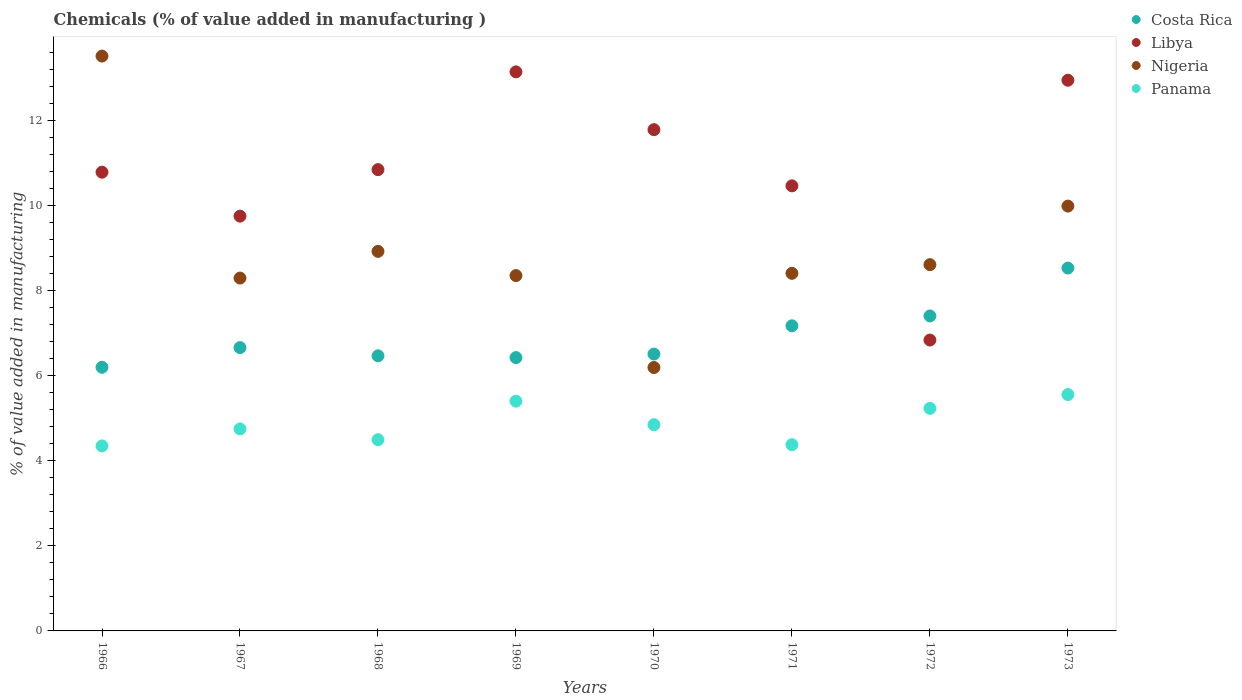What is the value added in manufacturing chemicals in Panama in 1971?
Your answer should be very brief. 4.38. Across all years, what is the maximum value added in manufacturing chemicals in Nigeria?
Your answer should be very brief. 13.52. Across all years, what is the minimum value added in manufacturing chemicals in Libya?
Keep it short and to the point. 6.84. In which year was the value added in manufacturing chemicals in Panama minimum?
Ensure brevity in your answer.  1966. What is the total value added in manufacturing chemicals in Libya in the graph?
Provide a succinct answer. 86.56. What is the difference between the value added in manufacturing chemicals in Costa Rica in 1967 and that in 1969?
Offer a very short reply. 0.24. What is the difference between the value added in manufacturing chemicals in Costa Rica in 1971 and the value added in manufacturing chemicals in Libya in 1967?
Your answer should be very brief. -2.58. What is the average value added in manufacturing chemicals in Panama per year?
Keep it short and to the point. 4.88. In the year 1971, what is the difference between the value added in manufacturing chemicals in Nigeria and value added in manufacturing chemicals in Costa Rica?
Provide a succinct answer. 1.23. In how many years, is the value added in manufacturing chemicals in Costa Rica greater than 7.2 %?
Provide a succinct answer. 2. What is the ratio of the value added in manufacturing chemicals in Panama in 1966 to that in 1970?
Your response must be concise. 0.9. What is the difference between the highest and the second highest value added in manufacturing chemicals in Costa Rica?
Provide a short and direct response. 1.13. What is the difference between the highest and the lowest value added in manufacturing chemicals in Costa Rica?
Your answer should be compact. 2.33. Does the value added in manufacturing chemicals in Costa Rica monotonically increase over the years?
Make the answer very short. No. Is the value added in manufacturing chemicals in Nigeria strictly greater than the value added in manufacturing chemicals in Libya over the years?
Offer a terse response. No. Is the value added in manufacturing chemicals in Libya strictly less than the value added in manufacturing chemicals in Costa Rica over the years?
Give a very brief answer. No. How many years are there in the graph?
Offer a terse response. 8. What is the difference between two consecutive major ticks on the Y-axis?
Provide a short and direct response. 2. Are the values on the major ticks of Y-axis written in scientific E-notation?
Your answer should be very brief. No. How are the legend labels stacked?
Offer a very short reply. Vertical. What is the title of the graph?
Provide a short and direct response. Chemicals (% of value added in manufacturing ). Does "Bahrain" appear as one of the legend labels in the graph?
Provide a succinct answer. No. What is the label or title of the X-axis?
Your answer should be compact. Years. What is the label or title of the Y-axis?
Offer a very short reply. % of value added in manufacturing. What is the % of value added in manufacturing in Costa Rica in 1966?
Offer a very short reply. 6.2. What is the % of value added in manufacturing in Libya in 1966?
Your response must be concise. 10.78. What is the % of value added in manufacturing of Nigeria in 1966?
Provide a short and direct response. 13.52. What is the % of value added in manufacturing of Panama in 1966?
Provide a short and direct response. 4.35. What is the % of value added in manufacturing of Costa Rica in 1967?
Your answer should be very brief. 6.66. What is the % of value added in manufacturing in Libya in 1967?
Your answer should be compact. 9.75. What is the % of value added in manufacturing of Nigeria in 1967?
Provide a short and direct response. 8.3. What is the % of value added in manufacturing in Panama in 1967?
Your answer should be compact. 4.75. What is the % of value added in manufacturing of Costa Rica in 1968?
Keep it short and to the point. 6.47. What is the % of value added in manufacturing of Libya in 1968?
Make the answer very short. 10.85. What is the % of value added in manufacturing in Nigeria in 1968?
Your response must be concise. 8.92. What is the % of value added in manufacturing of Panama in 1968?
Make the answer very short. 4.5. What is the % of value added in manufacturing of Costa Rica in 1969?
Provide a short and direct response. 6.43. What is the % of value added in manufacturing of Libya in 1969?
Your answer should be compact. 13.14. What is the % of value added in manufacturing of Nigeria in 1969?
Offer a terse response. 8.35. What is the % of value added in manufacturing in Panama in 1969?
Your answer should be compact. 5.4. What is the % of value added in manufacturing of Costa Rica in 1970?
Keep it short and to the point. 6.51. What is the % of value added in manufacturing in Libya in 1970?
Ensure brevity in your answer.  11.79. What is the % of value added in manufacturing of Nigeria in 1970?
Make the answer very short. 6.19. What is the % of value added in manufacturing of Panama in 1970?
Provide a short and direct response. 4.85. What is the % of value added in manufacturing in Costa Rica in 1971?
Provide a short and direct response. 7.17. What is the % of value added in manufacturing of Libya in 1971?
Make the answer very short. 10.46. What is the % of value added in manufacturing in Nigeria in 1971?
Make the answer very short. 8.41. What is the % of value added in manufacturing in Panama in 1971?
Make the answer very short. 4.38. What is the % of value added in manufacturing of Costa Rica in 1972?
Your response must be concise. 7.41. What is the % of value added in manufacturing in Libya in 1972?
Keep it short and to the point. 6.84. What is the % of value added in manufacturing in Nigeria in 1972?
Give a very brief answer. 8.61. What is the % of value added in manufacturing in Panama in 1972?
Your response must be concise. 5.23. What is the % of value added in manufacturing in Costa Rica in 1973?
Your answer should be very brief. 8.53. What is the % of value added in manufacturing of Libya in 1973?
Offer a very short reply. 12.95. What is the % of value added in manufacturing in Nigeria in 1973?
Your answer should be very brief. 9.99. What is the % of value added in manufacturing of Panama in 1973?
Give a very brief answer. 5.56. Across all years, what is the maximum % of value added in manufacturing of Costa Rica?
Your answer should be compact. 8.53. Across all years, what is the maximum % of value added in manufacturing in Libya?
Keep it short and to the point. 13.14. Across all years, what is the maximum % of value added in manufacturing of Nigeria?
Keep it short and to the point. 13.52. Across all years, what is the maximum % of value added in manufacturing in Panama?
Your answer should be very brief. 5.56. Across all years, what is the minimum % of value added in manufacturing of Costa Rica?
Provide a short and direct response. 6.2. Across all years, what is the minimum % of value added in manufacturing of Libya?
Provide a succinct answer. 6.84. Across all years, what is the minimum % of value added in manufacturing of Nigeria?
Give a very brief answer. 6.19. Across all years, what is the minimum % of value added in manufacturing in Panama?
Your response must be concise. 4.35. What is the total % of value added in manufacturing in Costa Rica in the graph?
Your answer should be very brief. 55.37. What is the total % of value added in manufacturing of Libya in the graph?
Your response must be concise. 86.56. What is the total % of value added in manufacturing in Nigeria in the graph?
Offer a very short reply. 72.29. What is the total % of value added in manufacturing in Panama in the graph?
Ensure brevity in your answer.  39.01. What is the difference between the % of value added in manufacturing of Costa Rica in 1966 and that in 1967?
Provide a succinct answer. -0.46. What is the difference between the % of value added in manufacturing in Libya in 1966 and that in 1967?
Provide a short and direct response. 1.03. What is the difference between the % of value added in manufacturing in Nigeria in 1966 and that in 1967?
Provide a succinct answer. 5.22. What is the difference between the % of value added in manufacturing of Panama in 1966 and that in 1967?
Offer a terse response. -0.4. What is the difference between the % of value added in manufacturing of Costa Rica in 1966 and that in 1968?
Give a very brief answer. -0.27. What is the difference between the % of value added in manufacturing of Libya in 1966 and that in 1968?
Ensure brevity in your answer.  -0.06. What is the difference between the % of value added in manufacturing of Nigeria in 1966 and that in 1968?
Offer a very short reply. 4.59. What is the difference between the % of value added in manufacturing in Panama in 1966 and that in 1968?
Offer a very short reply. -0.15. What is the difference between the % of value added in manufacturing in Costa Rica in 1966 and that in 1969?
Your answer should be compact. -0.23. What is the difference between the % of value added in manufacturing of Libya in 1966 and that in 1969?
Ensure brevity in your answer.  -2.36. What is the difference between the % of value added in manufacturing in Nigeria in 1966 and that in 1969?
Offer a terse response. 5.16. What is the difference between the % of value added in manufacturing of Panama in 1966 and that in 1969?
Offer a very short reply. -1.05. What is the difference between the % of value added in manufacturing of Costa Rica in 1966 and that in 1970?
Your answer should be compact. -0.31. What is the difference between the % of value added in manufacturing in Libya in 1966 and that in 1970?
Provide a short and direct response. -1. What is the difference between the % of value added in manufacturing of Nigeria in 1966 and that in 1970?
Keep it short and to the point. 7.32. What is the difference between the % of value added in manufacturing of Panama in 1966 and that in 1970?
Your response must be concise. -0.5. What is the difference between the % of value added in manufacturing of Costa Rica in 1966 and that in 1971?
Make the answer very short. -0.97. What is the difference between the % of value added in manufacturing of Libya in 1966 and that in 1971?
Provide a succinct answer. 0.32. What is the difference between the % of value added in manufacturing in Nigeria in 1966 and that in 1971?
Keep it short and to the point. 5.11. What is the difference between the % of value added in manufacturing in Panama in 1966 and that in 1971?
Your answer should be compact. -0.03. What is the difference between the % of value added in manufacturing in Costa Rica in 1966 and that in 1972?
Keep it short and to the point. -1.21. What is the difference between the % of value added in manufacturing of Libya in 1966 and that in 1972?
Your answer should be very brief. 3.95. What is the difference between the % of value added in manufacturing in Nigeria in 1966 and that in 1972?
Your answer should be very brief. 4.9. What is the difference between the % of value added in manufacturing in Panama in 1966 and that in 1972?
Offer a very short reply. -0.88. What is the difference between the % of value added in manufacturing of Costa Rica in 1966 and that in 1973?
Offer a terse response. -2.33. What is the difference between the % of value added in manufacturing of Libya in 1966 and that in 1973?
Give a very brief answer. -2.16. What is the difference between the % of value added in manufacturing of Nigeria in 1966 and that in 1973?
Provide a succinct answer. 3.53. What is the difference between the % of value added in manufacturing in Panama in 1966 and that in 1973?
Provide a succinct answer. -1.21. What is the difference between the % of value added in manufacturing of Costa Rica in 1967 and that in 1968?
Offer a terse response. 0.19. What is the difference between the % of value added in manufacturing of Libya in 1967 and that in 1968?
Ensure brevity in your answer.  -1.09. What is the difference between the % of value added in manufacturing of Nigeria in 1967 and that in 1968?
Your answer should be compact. -0.63. What is the difference between the % of value added in manufacturing of Panama in 1967 and that in 1968?
Provide a short and direct response. 0.25. What is the difference between the % of value added in manufacturing of Costa Rica in 1967 and that in 1969?
Make the answer very short. 0.24. What is the difference between the % of value added in manufacturing in Libya in 1967 and that in 1969?
Provide a short and direct response. -3.39. What is the difference between the % of value added in manufacturing of Nigeria in 1967 and that in 1969?
Offer a very short reply. -0.06. What is the difference between the % of value added in manufacturing of Panama in 1967 and that in 1969?
Provide a succinct answer. -0.65. What is the difference between the % of value added in manufacturing of Costa Rica in 1967 and that in 1970?
Give a very brief answer. 0.15. What is the difference between the % of value added in manufacturing of Libya in 1967 and that in 1970?
Offer a very short reply. -2.03. What is the difference between the % of value added in manufacturing of Nigeria in 1967 and that in 1970?
Make the answer very short. 2.1. What is the difference between the % of value added in manufacturing in Panama in 1967 and that in 1970?
Provide a short and direct response. -0.1. What is the difference between the % of value added in manufacturing of Costa Rica in 1967 and that in 1971?
Your answer should be compact. -0.51. What is the difference between the % of value added in manufacturing in Libya in 1967 and that in 1971?
Keep it short and to the point. -0.71. What is the difference between the % of value added in manufacturing in Nigeria in 1967 and that in 1971?
Ensure brevity in your answer.  -0.11. What is the difference between the % of value added in manufacturing in Panama in 1967 and that in 1971?
Your answer should be compact. 0.37. What is the difference between the % of value added in manufacturing of Costa Rica in 1967 and that in 1972?
Offer a terse response. -0.74. What is the difference between the % of value added in manufacturing of Libya in 1967 and that in 1972?
Ensure brevity in your answer.  2.91. What is the difference between the % of value added in manufacturing in Nigeria in 1967 and that in 1972?
Your answer should be very brief. -0.32. What is the difference between the % of value added in manufacturing in Panama in 1967 and that in 1972?
Ensure brevity in your answer.  -0.48. What is the difference between the % of value added in manufacturing in Costa Rica in 1967 and that in 1973?
Your response must be concise. -1.87. What is the difference between the % of value added in manufacturing of Libya in 1967 and that in 1973?
Your response must be concise. -3.2. What is the difference between the % of value added in manufacturing of Nigeria in 1967 and that in 1973?
Your response must be concise. -1.69. What is the difference between the % of value added in manufacturing of Panama in 1967 and that in 1973?
Give a very brief answer. -0.81. What is the difference between the % of value added in manufacturing in Costa Rica in 1968 and that in 1969?
Keep it short and to the point. 0.04. What is the difference between the % of value added in manufacturing in Libya in 1968 and that in 1969?
Provide a succinct answer. -2.3. What is the difference between the % of value added in manufacturing of Nigeria in 1968 and that in 1969?
Make the answer very short. 0.57. What is the difference between the % of value added in manufacturing of Panama in 1968 and that in 1969?
Keep it short and to the point. -0.91. What is the difference between the % of value added in manufacturing of Costa Rica in 1968 and that in 1970?
Provide a short and direct response. -0.04. What is the difference between the % of value added in manufacturing of Libya in 1968 and that in 1970?
Offer a terse response. -0.94. What is the difference between the % of value added in manufacturing in Nigeria in 1968 and that in 1970?
Keep it short and to the point. 2.73. What is the difference between the % of value added in manufacturing in Panama in 1968 and that in 1970?
Offer a terse response. -0.35. What is the difference between the % of value added in manufacturing of Costa Rica in 1968 and that in 1971?
Give a very brief answer. -0.71. What is the difference between the % of value added in manufacturing in Libya in 1968 and that in 1971?
Your answer should be compact. 0.38. What is the difference between the % of value added in manufacturing in Nigeria in 1968 and that in 1971?
Provide a succinct answer. 0.52. What is the difference between the % of value added in manufacturing of Panama in 1968 and that in 1971?
Provide a short and direct response. 0.12. What is the difference between the % of value added in manufacturing of Costa Rica in 1968 and that in 1972?
Keep it short and to the point. -0.94. What is the difference between the % of value added in manufacturing of Libya in 1968 and that in 1972?
Offer a terse response. 4.01. What is the difference between the % of value added in manufacturing in Nigeria in 1968 and that in 1972?
Provide a short and direct response. 0.31. What is the difference between the % of value added in manufacturing of Panama in 1968 and that in 1972?
Offer a terse response. -0.74. What is the difference between the % of value added in manufacturing of Costa Rica in 1968 and that in 1973?
Your response must be concise. -2.06. What is the difference between the % of value added in manufacturing of Libya in 1968 and that in 1973?
Give a very brief answer. -2.1. What is the difference between the % of value added in manufacturing of Nigeria in 1968 and that in 1973?
Give a very brief answer. -1.06. What is the difference between the % of value added in manufacturing of Panama in 1968 and that in 1973?
Keep it short and to the point. -1.06. What is the difference between the % of value added in manufacturing in Costa Rica in 1969 and that in 1970?
Keep it short and to the point. -0.08. What is the difference between the % of value added in manufacturing in Libya in 1969 and that in 1970?
Make the answer very short. 1.36. What is the difference between the % of value added in manufacturing of Nigeria in 1969 and that in 1970?
Provide a succinct answer. 2.16. What is the difference between the % of value added in manufacturing of Panama in 1969 and that in 1970?
Offer a terse response. 0.55. What is the difference between the % of value added in manufacturing of Costa Rica in 1969 and that in 1971?
Provide a short and direct response. -0.75. What is the difference between the % of value added in manufacturing of Libya in 1969 and that in 1971?
Your response must be concise. 2.68. What is the difference between the % of value added in manufacturing of Nigeria in 1969 and that in 1971?
Keep it short and to the point. -0.05. What is the difference between the % of value added in manufacturing of Panama in 1969 and that in 1971?
Offer a very short reply. 1.02. What is the difference between the % of value added in manufacturing of Costa Rica in 1969 and that in 1972?
Your answer should be compact. -0.98. What is the difference between the % of value added in manufacturing in Libya in 1969 and that in 1972?
Provide a short and direct response. 6.31. What is the difference between the % of value added in manufacturing in Nigeria in 1969 and that in 1972?
Give a very brief answer. -0.26. What is the difference between the % of value added in manufacturing of Panama in 1969 and that in 1972?
Provide a short and direct response. 0.17. What is the difference between the % of value added in manufacturing of Costa Rica in 1969 and that in 1973?
Ensure brevity in your answer.  -2.11. What is the difference between the % of value added in manufacturing of Libya in 1969 and that in 1973?
Give a very brief answer. 0.2. What is the difference between the % of value added in manufacturing in Nigeria in 1969 and that in 1973?
Offer a very short reply. -1.63. What is the difference between the % of value added in manufacturing in Panama in 1969 and that in 1973?
Give a very brief answer. -0.15. What is the difference between the % of value added in manufacturing of Costa Rica in 1970 and that in 1971?
Provide a succinct answer. -0.66. What is the difference between the % of value added in manufacturing of Libya in 1970 and that in 1971?
Provide a succinct answer. 1.32. What is the difference between the % of value added in manufacturing in Nigeria in 1970 and that in 1971?
Make the answer very short. -2.21. What is the difference between the % of value added in manufacturing of Panama in 1970 and that in 1971?
Ensure brevity in your answer.  0.47. What is the difference between the % of value added in manufacturing in Costa Rica in 1970 and that in 1972?
Offer a terse response. -0.9. What is the difference between the % of value added in manufacturing in Libya in 1970 and that in 1972?
Make the answer very short. 4.95. What is the difference between the % of value added in manufacturing of Nigeria in 1970 and that in 1972?
Give a very brief answer. -2.42. What is the difference between the % of value added in manufacturing in Panama in 1970 and that in 1972?
Provide a short and direct response. -0.38. What is the difference between the % of value added in manufacturing of Costa Rica in 1970 and that in 1973?
Your response must be concise. -2.02. What is the difference between the % of value added in manufacturing of Libya in 1970 and that in 1973?
Provide a short and direct response. -1.16. What is the difference between the % of value added in manufacturing of Nigeria in 1970 and that in 1973?
Offer a terse response. -3.8. What is the difference between the % of value added in manufacturing in Panama in 1970 and that in 1973?
Your response must be concise. -0.71. What is the difference between the % of value added in manufacturing of Costa Rica in 1971 and that in 1972?
Make the answer very short. -0.23. What is the difference between the % of value added in manufacturing of Libya in 1971 and that in 1972?
Provide a succinct answer. 3.63. What is the difference between the % of value added in manufacturing of Nigeria in 1971 and that in 1972?
Provide a succinct answer. -0.2. What is the difference between the % of value added in manufacturing in Panama in 1971 and that in 1972?
Ensure brevity in your answer.  -0.85. What is the difference between the % of value added in manufacturing in Costa Rica in 1971 and that in 1973?
Your response must be concise. -1.36. What is the difference between the % of value added in manufacturing of Libya in 1971 and that in 1973?
Provide a short and direct response. -2.48. What is the difference between the % of value added in manufacturing of Nigeria in 1971 and that in 1973?
Your response must be concise. -1.58. What is the difference between the % of value added in manufacturing in Panama in 1971 and that in 1973?
Your answer should be compact. -1.18. What is the difference between the % of value added in manufacturing of Costa Rica in 1972 and that in 1973?
Make the answer very short. -1.13. What is the difference between the % of value added in manufacturing in Libya in 1972 and that in 1973?
Your answer should be compact. -6.11. What is the difference between the % of value added in manufacturing in Nigeria in 1972 and that in 1973?
Provide a short and direct response. -1.38. What is the difference between the % of value added in manufacturing of Panama in 1972 and that in 1973?
Your answer should be compact. -0.32. What is the difference between the % of value added in manufacturing in Costa Rica in 1966 and the % of value added in manufacturing in Libya in 1967?
Ensure brevity in your answer.  -3.55. What is the difference between the % of value added in manufacturing in Costa Rica in 1966 and the % of value added in manufacturing in Nigeria in 1967?
Your response must be concise. -2.1. What is the difference between the % of value added in manufacturing of Costa Rica in 1966 and the % of value added in manufacturing of Panama in 1967?
Give a very brief answer. 1.45. What is the difference between the % of value added in manufacturing of Libya in 1966 and the % of value added in manufacturing of Nigeria in 1967?
Ensure brevity in your answer.  2.49. What is the difference between the % of value added in manufacturing in Libya in 1966 and the % of value added in manufacturing in Panama in 1967?
Your response must be concise. 6.04. What is the difference between the % of value added in manufacturing of Nigeria in 1966 and the % of value added in manufacturing of Panama in 1967?
Provide a short and direct response. 8.77. What is the difference between the % of value added in manufacturing in Costa Rica in 1966 and the % of value added in manufacturing in Libya in 1968?
Keep it short and to the point. -4.65. What is the difference between the % of value added in manufacturing of Costa Rica in 1966 and the % of value added in manufacturing of Nigeria in 1968?
Ensure brevity in your answer.  -2.73. What is the difference between the % of value added in manufacturing of Costa Rica in 1966 and the % of value added in manufacturing of Panama in 1968?
Your answer should be very brief. 1.7. What is the difference between the % of value added in manufacturing of Libya in 1966 and the % of value added in manufacturing of Nigeria in 1968?
Offer a very short reply. 1.86. What is the difference between the % of value added in manufacturing of Libya in 1966 and the % of value added in manufacturing of Panama in 1968?
Your response must be concise. 6.29. What is the difference between the % of value added in manufacturing of Nigeria in 1966 and the % of value added in manufacturing of Panama in 1968?
Your response must be concise. 9.02. What is the difference between the % of value added in manufacturing in Costa Rica in 1966 and the % of value added in manufacturing in Libya in 1969?
Your response must be concise. -6.95. What is the difference between the % of value added in manufacturing of Costa Rica in 1966 and the % of value added in manufacturing of Nigeria in 1969?
Your response must be concise. -2.16. What is the difference between the % of value added in manufacturing of Costa Rica in 1966 and the % of value added in manufacturing of Panama in 1969?
Provide a succinct answer. 0.8. What is the difference between the % of value added in manufacturing in Libya in 1966 and the % of value added in manufacturing in Nigeria in 1969?
Provide a succinct answer. 2.43. What is the difference between the % of value added in manufacturing in Libya in 1966 and the % of value added in manufacturing in Panama in 1969?
Keep it short and to the point. 5.38. What is the difference between the % of value added in manufacturing of Nigeria in 1966 and the % of value added in manufacturing of Panama in 1969?
Offer a very short reply. 8.11. What is the difference between the % of value added in manufacturing of Costa Rica in 1966 and the % of value added in manufacturing of Libya in 1970?
Your response must be concise. -5.59. What is the difference between the % of value added in manufacturing in Costa Rica in 1966 and the % of value added in manufacturing in Nigeria in 1970?
Ensure brevity in your answer.  0.01. What is the difference between the % of value added in manufacturing in Costa Rica in 1966 and the % of value added in manufacturing in Panama in 1970?
Offer a terse response. 1.35. What is the difference between the % of value added in manufacturing in Libya in 1966 and the % of value added in manufacturing in Nigeria in 1970?
Keep it short and to the point. 4.59. What is the difference between the % of value added in manufacturing in Libya in 1966 and the % of value added in manufacturing in Panama in 1970?
Provide a short and direct response. 5.94. What is the difference between the % of value added in manufacturing of Nigeria in 1966 and the % of value added in manufacturing of Panama in 1970?
Give a very brief answer. 8.67. What is the difference between the % of value added in manufacturing in Costa Rica in 1966 and the % of value added in manufacturing in Libya in 1971?
Offer a terse response. -4.27. What is the difference between the % of value added in manufacturing of Costa Rica in 1966 and the % of value added in manufacturing of Nigeria in 1971?
Your answer should be compact. -2.21. What is the difference between the % of value added in manufacturing in Costa Rica in 1966 and the % of value added in manufacturing in Panama in 1971?
Offer a terse response. 1.82. What is the difference between the % of value added in manufacturing in Libya in 1966 and the % of value added in manufacturing in Nigeria in 1971?
Offer a terse response. 2.38. What is the difference between the % of value added in manufacturing in Libya in 1966 and the % of value added in manufacturing in Panama in 1971?
Offer a very short reply. 6.41. What is the difference between the % of value added in manufacturing in Nigeria in 1966 and the % of value added in manufacturing in Panama in 1971?
Offer a terse response. 9.14. What is the difference between the % of value added in manufacturing of Costa Rica in 1966 and the % of value added in manufacturing of Libya in 1972?
Your answer should be compact. -0.64. What is the difference between the % of value added in manufacturing of Costa Rica in 1966 and the % of value added in manufacturing of Nigeria in 1972?
Provide a succinct answer. -2.41. What is the difference between the % of value added in manufacturing in Costa Rica in 1966 and the % of value added in manufacturing in Panama in 1972?
Provide a short and direct response. 0.97. What is the difference between the % of value added in manufacturing in Libya in 1966 and the % of value added in manufacturing in Nigeria in 1972?
Your response must be concise. 2.17. What is the difference between the % of value added in manufacturing of Libya in 1966 and the % of value added in manufacturing of Panama in 1972?
Your response must be concise. 5.55. What is the difference between the % of value added in manufacturing of Nigeria in 1966 and the % of value added in manufacturing of Panama in 1972?
Your response must be concise. 8.28. What is the difference between the % of value added in manufacturing in Costa Rica in 1966 and the % of value added in manufacturing in Libya in 1973?
Ensure brevity in your answer.  -6.75. What is the difference between the % of value added in manufacturing of Costa Rica in 1966 and the % of value added in manufacturing of Nigeria in 1973?
Provide a short and direct response. -3.79. What is the difference between the % of value added in manufacturing in Costa Rica in 1966 and the % of value added in manufacturing in Panama in 1973?
Give a very brief answer. 0.64. What is the difference between the % of value added in manufacturing in Libya in 1966 and the % of value added in manufacturing in Nigeria in 1973?
Give a very brief answer. 0.8. What is the difference between the % of value added in manufacturing of Libya in 1966 and the % of value added in manufacturing of Panama in 1973?
Offer a terse response. 5.23. What is the difference between the % of value added in manufacturing in Nigeria in 1966 and the % of value added in manufacturing in Panama in 1973?
Provide a succinct answer. 7.96. What is the difference between the % of value added in manufacturing in Costa Rica in 1967 and the % of value added in manufacturing in Libya in 1968?
Provide a succinct answer. -4.18. What is the difference between the % of value added in manufacturing of Costa Rica in 1967 and the % of value added in manufacturing of Nigeria in 1968?
Provide a succinct answer. -2.26. What is the difference between the % of value added in manufacturing in Costa Rica in 1967 and the % of value added in manufacturing in Panama in 1968?
Your answer should be compact. 2.17. What is the difference between the % of value added in manufacturing of Libya in 1967 and the % of value added in manufacturing of Nigeria in 1968?
Make the answer very short. 0.83. What is the difference between the % of value added in manufacturing in Libya in 1967 and the % of value added in manufacturing in Panama in 1968?
Offer a very short reply. 5.26. What is the difference between the % of value added in manufacturing of Nigeria in 1967 and the % of value added in manufacturing of Panama in 1968?
Offer a very short reply. 3.8. What is the difference between the % of value added in manufacturing in Costa Rica in 1967 and the % of value added in manufacturing in Libya in 1969?
Your answer should be compact. -6.48. What is the difference between the % of value added in manufacturing of Costa Rica in 1967 and the % of value added in manufacturing of Nigeria in 1969?
Your answer should be very brief. -1.69. What is the difference between the % of value added in manufacturing in Costa Rica in 1967 and the % of value added in manufacturing in Panama in 1969?
Your answer should be compact. 1.26. What is the difference between the % of value added in manufacturing in Libya in 1967 and the % of value added in manufacturing in Nigeria in 1969?
Keep it short and to the point. 1.4. What is the difference between the % of value added in manufacturing in Libya in 1967 and the % of value added in manufacturing in Panama in 1969?
Offer a very short reply. 4.35. What is the difference between the % of value added in manufacturing of Nigeria in 1967 and the % of value added in manufacturing of Panama in 1969?
Your response must be concise. 2.89. What is the difference between the % of value added in manufacturing in Costa Rica in 1967 and the % of value added in manufacturing in Libya in 1970?
Make the answer very short. -5.12. What is the difference between the % of value added in manufacturing of Costa Rica in 1967 and the % of value added in manufacturing of Nigeria in 1970?
Offer a very short reply. 0.47. What is the difference between the % of value added in manufacturing of Costa Rica in 1967 and the % of value added in manufacturing of Panama in 1970?
Your response must be concise. 1.81. What is the difference between the % of value added in manufacturing in Libya in 1967 and the % of value added in manufacturing in Nigeria in 1970?
Provide a short and direct response. 3.56. What is the difference between the % of value added in manufacturing of Libya in 1967 and the % of value added in manufacturing of Panama in 1970?
Ensure brevity in your answer.  4.9. What is the difference between the % of value added in manufacturing in Nigeria in 1967 and the % of value added in manufacturing in Panama in 1970?
Your response must be concise. 3.45. What is the difference between the % of value added in manufacturing in Costa Rica in 1967 and the % of value added in manufacturing in Libya in 1971?
Provide a short and direct response. -3.8. What is the difference between the % of value added in manufacturing of Costa Rica in 1967 and the % of value added in manufacturing of Nigeria in 1971?
Offer a very short reply. -1.75. What is the difference between the % of value added in manufacturing in Costa Rica in 1967 and the % of value added in manufacturing in Panama in 1971?
Offer a terse response. 2.28. What is the difference between the % of value added in manufacturing in Libya in 1967 and the % of value added in manufacturing in Nigeria in 1971?
Give a very brief answer. 1.34. What is the difference between the % of value added in manufacturing of Libya in 1967 and the % of value added in manufacturing of Panama in 1971?
Offer a terse response. 5.37. What is the difference between the % of value added in manufacturing in Nigeria in 1967 and the % of value added in manufacturing in Panama in 1971?
Your response must be concise. 3.92. What is the difference between the % of value added in manufacturing of Costa Rica in 1967 and the % of value added in manufacturing of Libya in 1972?
Provide a succinct answer. -0.18. What is the difference between the % of value added in manufacturing in Costa Rica in 1967 and the % of value added in manufacturing in Nigeria in 1972?
Give a very brief answer. -1.95. What is the difference between the % of value added in manufacturing of Costa Rica in 1967 and the % of value added in manufacturing of Panama in 1972?
Provide a succinct answer. 1.43. What is the difference between the % of value added in manufacturing in Libya in 1967 and the % of value added in manufacturing in Nigeria in 1972?
Provide a short and direct response. 1.14. What is the difference between the % of value added in manufacturing in Libya in 1967 and the % of value added in manufacturing in Panama in 1972?
Provide a short and direct response. 4.52. What is the difference between the % of value added in manufacturing in Nigeria in 1967 and the % of value added in manufacturing in Panama in 1972?
Offer a terse response. 3.06. What is the difference between the % of value added in manufacturing of Costa Rica in 1967 and the % of value added in manufacturing of Libya in 1973?
Your answer should be very brief. -6.29. What is the difference between the % of value added in manufacturing of Costa Rica in 1967 and the % of value added in manufacturing of Nigeria in 1973?
Your answer should be very brief. -3.33. What is the difference between the % of value added in manufacturing in Costa Rica in 1967 and the % of value added in manufacturing in Panama in 1973?
Provide a short and direct response. 1.1. What is the difference between the % of value added in manufacturing in Libya in 1967 and the % of value added in manufacturing in Nigeria in 1973?
Provide a succinct answer. -0.24. What is the difference between the % of value added in manufacturing of Libya in 1967 and the % of value added in manufacturing of Panama in 1973?
Provide a succinct answer. 4.19. What is the difference between the % of value added in manufacturing of Nigeria in 1967 and the % of value added in manufacturing of Panama in 1973?
Your answer should be compact. 2.74. What is the difference between the % of value added in manufacturing of Costa Rica in 1968 and the % of value added in manufacturing of Libya in 1969?
Keep it short and to the point. -6.68. What is the difference between the % of value added in manufacturing in Costa Rica in 1968 and the % of value added in manufacturing in Nigeria in 1969?
Your response must be concise. -1.89. What is the difference between the % of value added in manufacturing in Costa Rica in 1968 and the % of value added in manufacturing in Panama in 1969?
Provide a succinct answer. 1.07. What is the difference between the % of value added in manufacturing of Libya in 1968 and the % of value added in manufacturing of Nigeria in 1969?
Give a very brief answer. 2.49. What is the difference between the % of value added in manufacturing in Libya in 1968 and the % of value added in manufacturing in Panama in 1969?
Make the answer very short. 5.44. What is the difference between the % of value added in manufacturing of Nigeria in 1968 and the % of value added in manufacturing of Panama in 1969?
Offer a terse response. 3.52. What is the difference between the % of value added in manufacturing of Costa Rica in 1968 and the % of value added in manufacturing of Libya in 1970?
Ensure brevity in your answer.  -5.32. What is the difference between the % of value added in manufacturing of Costa Rica in 1968 and the % of value added in manufacturing of Nigeria in 1970?
Give a very brief answer. 0.28. What is the difference between the % of value added in manufacturing of Costa Rica in 1968 and the % of value added in manufacturing of Panama in 1970?
Your answer should be compact. 1.62. What is the difference between the % of value added in manufacturing of Libya in 1968 and the % of value added in manufacturing of Nigeria in 1970?
Your answer should be very brief. 4.65. What is the difference between the % of value added in manufacturing of Libya in 1968 and the % of value added in manufacturing of Panama in 1970?
Offer a terse response. 6. What is the difference between the % of value added in manufacturing of Nigeria in 1968 and the % of value added in manufacturing of Panama in 1970?
Provide a succinct answer. 4.08. What is the difference between the % of value added in manufacturing of Costa Rica in 1968 and the % of value added in manufacturing of Libya in 1971?
Provide a short and direct response. -4. What is the difference between the % of value added in manufacturing in Costa Rica in 1968 and the % of value added in manufacturing in Nigeria in 1971?
Your answer should be very brief. -1.94. What is the difference between the % of value added in manufacturing of Costa Rica in 1968 and the % of value added in manufacturing of Panama in 1971?
Offer a terse response. 2.09. What is the difference between the % of value added in manufacturing of Libya in 1968 and the % of value added in manufacturing of Nigeria in 1971?
Give a very brief answer. 2.44. What is the difference between the % of value added in manufacturing in Libya in 1968 and the % of value added in manufacturing in Panama in 1971?
Make the answer very short. 6.47. What is the difference between the % of value added in manufacturing of Nigeria in 1968 and the % of value added in manufacturing of Panama in 1971?
Your answer should be very brief. 4.55. What is the difference between the % of value added in manufacturing of Costa Rica in 1968 and the % of value added in manufacturing of Libya in 1972?
Ensure brevity in your answer.  -0.37. What is the difference between the % of value added in manufacturing in Costa Rica in 1968 and the % of value added in manufacturing in Nigeria in 1972?
Your response must be concise. -2.14. What is the difference between the % of value added in manufacturing in Costa Rica in 1968 and the % of value added in manufacturing in Panama in 1972?
Your answer should be very brief. 1.24. What is the difference between the % of value added in manufacturing of Libya in 1968 and the % of value added in manufacturing of Nigeria in 1972?
Ensure brevity in your answer.  2.23. What is the difference between the % of value added in manufacturing in Libya in 1968 and the % of value added in manufacturing in Panama in 1972?
Offer a terse response. 5.61. What is the difference between the % of value added in manufacturing in Nigeria in 1968 and the % of value added in manufacturing in Panama in 1972?
Give a very brief answer. 3.69. What is the difference between the % of value added in manufacturing in Costa Rica in 1968 and the % of value added in manufacturing in Libya in 1973?
Offer a terse response. -6.48. What is the difference between the % of value added in manufacturing in Costa Rica in 1968 and the % of value added in manufacturing in Nigeria in 1973?
Your answer should be very brief. -3.52. What is the difference between the % of value added in manufacturing in Costa Rica in 1968 and the % of value added in manufacturing in Panama in 1973?
Ensure brevity in your answer.  0.91. What is the difference between the % of value added in manufacturing of Libya in 1968 and the % of value added in manufacturing of Nigeria in 1973?
Your answer should be very brief. 0.86. What is the difference between the % of value added in manufacturing of Libya in 1968 and the % of value added in manufacturing of Panama in 1973?
Provide a short and direct response. 5.29. What is the difference between the % of value added in manufacturing in Nigeria in 1968 and the % of value added in manufacturing in Panama in 1973?
Make the answer very short. 3.37. What is the difference between the % of value added in manufacturing in Costa Rica in 1969 and the % of value added in manufacturing in Libya in 1970?
Your answer should be very brief. -5.36. What is the difference between the % of value added in manufacturing in Costa Rica in 1969 and the % of value added in manufacturing in Nigeria in 1970?
Make the answer very short. 0.23. What is the difference between the % of value added in manufacturing of Costa Rica in 1969 and the % of value added in manufacturing of Panama in 1970?
Your response must be concise. 1.58. What is the difference between the % of value added in manufacturing of Libya in 1969 and the % of value added in manufacturing of Nigeria in 1970?
Your answer should be compact. 6.95. What is the difference between the % of value added in manufacturing of Libya in 1969 and the % of value added in manufacturing of Panama in 1970?
Your answer should be compact. 8.3. What is the difference between the % of value added in manufacturing in Nigeria in 1969 and the % of value added in manufacturing in Panama in 1970?
Offer a very short reply. 3.51. What is the difference between the % of value added in manufacturing of Costa Rica in 1969 and the % of value added in manufacturing of Libya in 1971?
Give a very brief answer. -4.04. What is the difference between the % of value added in manufacturing in Costa Rica in 1969 and the % of value added in manufacturing in Nigeria in 1971?
Ensure brevity in your answer.  -1.98. What is the difference between the % of value added in manufacturing of Costa Rica in 1969 and the % of value added in manufacturing of Panama in 1971?
Your answer should be very brief. 2.05. What is the difference between the % of value added in manufacturing of Libya in 1969 and the % of value added in manufacturing of Nigeria in 1971?
Your response must be concise. 4.74. What is the difference between the % of value added in manufacturing in Libya in 1969 and the % of value added in manufacturing in Panama in 1971?
Your answer should be compact. 8.77. What is the difference between the % of value added in manufacturing of Nigeria in 1969 and the % of value added in manufacturing of Panama in 1971?
Your answer should be compact. 3.98. What is the difference between the % of value added in manufacturing of Costa Rica in 1969 and the % of value added in manufacturing of Libya in 1972?
Offer a terse response. -0.41. What is the difference between the % of value added in manufacturing of Costa Rica in 1969 and the % of value added in manufacturing of Nigeria in 1972?
Your response must be concise. -2.19. What is the difference between the % of value added in manufacturing of Costa Rica in 1969 and the % of value added in manufacturing of Panama in 1972?
Your response must be concise. 1.19. What is the difference between the % of value added in manufacturing in Libya in 1969 and the % of value added in manufacturing in Nigeria in 1972?
Ensure brevity in your answer.  4.53. What is the difference between the % of value added in manufacturing of Libya in 1969 and the % of value added in manufacturing of Panama in 1972?
Provide a succinct answer. 7.91. What is the difference between the % of value added in manufacturing in Nigeria in 1969 and the % of value added in manufacturing in Panama in 1972?
Ensure brevity in your answer.  3.12. What is the difference between the % of value added in manufacturing of Costa Rica in 1969 and the % of value added in manufacturing of Libya in 1973?
Offer a terse response. -6.52. What is the difference between the % of value added in manufacturing in Costa Rica in 1969 and the % of value added in manufacturing in Nigeria in 1973?
Give a very brief answer. -3.56. What is the difference between the % of value added in manufacturing in Costa Rica in 1969 and the % of value added in manufacturing in Panama in 1973?
Your answer should be very brief. 0.87. What is the difference between the % of value added in manufacturing in Libya in 1969 and the % of value added in manufacturing in Nigeria in 1973?
Your answer should be compact. 3.16. What is the difference between the % of value added in manufacturing of Libya in 1969 and the % of value added in manufacturing of Panama in 1973?
Make the answer very short. 7.59. What is the difference between the % of value added in manufacturing in Nigeria in 1969 and the % of value added in manufacturing in Panama in 1973?
Ensure brevity in your answer.  2.8. What is the difference between the % of value added in manufacturing in Costa Rica in 1970 and the % of value added in manufacturing in Libya in 1971?
Give a very brief answer. -3.96. What is the difference between the % of value added in manufacturing of Costa Rica in 1970 and the % of value added in manufacturing of Nigeria in 1971?
Your response must be concise. -1.9. What is the difference between the % of value added in manufacturing in Costa Rica in 1970 and the % of value added in manufacturing in Panama in 1971?
Ensure brevity in your answer.  2.13. What is the difference between the % of value added in manufacturing in Libya in 1970 and the % of value added in manufacturing in Nigeria in 1971?
Provide a short and direct response. 3.38. What is the difference between the % of value added in manufacturing of Libya in 1970 and the % of value added in manufacturing of Panama in 1971?
Make the answer very short. 7.41. What is the difference between the % of value added in manufacturing in Nigeria in 1970 and the % of value added in manufacturing in Panama in 1971?
Provide a succinct answer. 1.81. What is the difference between the % of value added in manufacturing in Costa Rica in 1970 and the % of value added in manufacturing in Libya in 1972?
Your answer should be very brief. -0.33. What is the difference between the % of value added in manufacturing in Costa Rica in 1970 and the % of value added in manufacturing in Nigeria in 1972?
Keep it short and to the point. -2.1. What is the difference between the % of value added in manufacturing of Costa Rica in 1970 and the % of value added in manufacturing of Panama in 1972?
Keep it short and to the point. 1.28. What is the difference between the % of value added in manufacturing of Libya in 1970 and the % of value added in manufacturing of Nigeria in 1972?
Make the answer very short. 3.17. What is the difference between the % of value added in manufacturing of Libya in 1970 and the % of value added in manufacturing of Panama in 1972?
Give a very brief answer. 6.55. What is the difference between the % of value added in manufacturing of Nigeria in 1970 and the % of value added in manufacturing of Panama in 1972?
Provide a short and direct response. 0.96. What is the difference between the % of value added in manufacturing in Costa Rica in 1970 and the % of value added in manufacturing in Libya in 1973?
Offer a terse response. -6.44. What is the difference between the % of value added in manufacturing of Costa Rica in 1970 and the % of value added in manufacturing of Nigeria in 1973?
Offer a terse response. -3.48. What is the difference between the % of value added in manufacturing of Libya in 1970 and the % of value added in manufacturing of Nigeria in 1973?
Your answer should be compact. 1.8. What is the difference between the % of value added in manufacturing of Libya in 1970 and the % of value added in manufacturing of Panama in 1973?
Your answer should be very brief. 6.23. What is the difference between the % of value added in manufacturing of Nigeria in 1970 and the % of value added in manufacturing of Panama in 1973?
Offer a very short reply. 0.64. What is the difference between the % of value added in manufacturing in Costa Rica in 1971 and the % of value added in manufacturing in Libya in 1972?
Your answer should be very brief. 0.33. What is the difference between the % of value added in manufacturing of Costa Rica in 1971 and the % of value added in manufacturing of Nigeria in 1972?
Your response must be concise. -1.44. What is the difference between the % of value added in manufacturing of Costa Rica in 1971 and the % of value added in manufacturing of Panama in 1972?
Provide a short and direct response. 1.94. What is the difference between the % of value added in manufacturing of Libya in 1971 and the % of value added in manufacturing of Nigeria in 1972?
Offer a very short reply. 1.85. What is the difference between the % of value added in manufacturing of Libya in 1971 and the % of value added in manufacturing of Panama in 1972?
Offer a very short reply. 5.23. What is the difference between the % of value added in manufacturing in Nigeria in 1971 and the % of value added in manufacturing in Panama in 1972?
Keep it short and to the point. 3.17. What is the difference between the % of value added in manufacturing of Costa Rica in 1971 and the % of value added in manufacturing of Libya in 1973?
Your answer should be very brief. -5.77. What is the difference between the % of value added in manufacturing of Costa Rica in 1971 and the % of value added in manufacturing of Nigeria in 1973?
Make the answer very short. -2.82. What is the difference between the % of value added in manufacturing in Costa Rica in 1971 and the % of value added in manufacturing in Panama in 1973?
Offer a very short reply. 1.62. What is the difference between the % of value added in manufacturing of Libya in 1971 and the % of value added in manufacturing of Nigeria in 1973?
Your answer should be compact. 0.48. What is the difference between the % of value added in manufacturing in Libya in 1971 and the % of value added in manufacturing in Panama in 1973?
Ensure brevity in your answer.  4.91. What is the difference between the % of value added in manufacturing in Nigeria in 1971 and the % of value added in manufacturing in Panama in 1973?
Make the answer very short. 2.85. What is the difference between the % of value added in manufacturing in Costa Rica in 1972 and the % of value added in manufacturing in Libya in 1973?
Your answer should be compact. -5.54. What is the difference between the % of value added in manufacturing of Costa Rica in 1972 and the % of value added in manufacturing of Nigeria in 1973?
Ensure brevity in your answer.  -2.58. What is the difference between the % of value added in manufacturing in Costa Rica in 1972 and the % of value added in manufacturing in Panama in 1973?
Give a very brief answer. 1.85. What is the difference between the % of value added in manufacturing in Libya in 1972 and the % of value added in manufacturing in Nigeria in 1973?
Make the answer very short. -3.15. What is the difference between the % of value added in manufacturing in Libya in 1972 and the % of value added in manufacturing in Panama in 1973?
Give a very brief answer. 1.28. What is the difference between the % of value added in manufacturing in Nigeria in 1972 and the % of value added in manufacturing in Panama in 1973?
Ensure brevity in your answer.  3.05. What is the average % of value added in manufacturing of Costa Rica per year?
Provide a succinct answer. 6.92. What is the average % of value added in manufacturing in Libya per year?
Your answer should be compact. 10.82. What is the average % of value added in manufacturing in Nigeria per year?
Make the answer very short. 9.04. What is the average % of value added in manufacturing of Panama per year?
Provide a succinct answer. 4.88. In the year 1966, what is the difference between the % of value added in manufacturing in Costa Rica and % of value added in manufacturing in Libya?
Make the answer very short. -4.59. In the year 1966, what is the difference between the % of value added in manufacturing in Costa Rica and % of value added in manufacturing in Nigeria?
Ensure brevity in your answer.  -7.32. In the year 1966, what is the difference between the % of value added in manufacturing in Costa Rica and % of value added in manufacturing in Panama?
Give a very brief answer. 1.85. In the year 1966, what is the difference between the % of value added in manufacturing in Libya and % of value added in manufacturing in Nigeria?
Give a very brief answer. -2.73. In the year 1966, what is the difference between the % of value added in manufacturing of Libya and % of value added in manufacturing of Panama?
Provide a succinct answer. 6.44. In the year 1966, what is the difference between the % of value added in manufacturing in Nigeria and % of value added in manufacturing in Panama?
Provide a short and direct response. 9.17. In the year 1967, what is the difference between the % of value added in manufacturing of Costa Rica and % of value added in manufacturing of Libya?
Your answer should be compact. -3.09. In the year 1967, what is the difference between the % of value added in manufacturing in Costa Rica and % of value added in manufacturing in Nigeria?
Offer a very short reply. -1.63. In the year 1967, what is the difference between the % of value added in manufacturing of Costa Rica and % of value added in manufacturing of Panama?
Your response must be concise. 1.91. In the year 1967, what is the difference between the % of value added in manufacturing of Libya and % of value added in manufacturing of Nigeria?
Offer a very short reply. 1.46. In the year 1967, what is the difference between the % of value added in manufacturing in Libya and % of value added in manufacturing in Panama?
Your response must be concise. 5. In the year 1967, what is the difference between the % of value added in manufacturing in Nigeria and % of value added in manufacturing in Panama?
Give a very brief answer. 3.55. In the year 1968, what is the difference between the % of value added in manufacturing of Costa Rica and % of value added in manufacturing of Libya?
Offer a terse response. -4.38. In the year 1968, what is the difference between the % of value added in manufacturing in Costa Rica and % of value added in manufacturing in Nigeria?
Ensure brevity in your answer.  -2.46. In the year 1968, what is the difference between the % of value added in manufacturing in Costa Rica and % of value added in manufacturing in Panama?
Your response must be concise. 1.97. In the year 1968, what is the difference between the % of value added in manufacturing of Libya and % of value added in manufacturing of Nigeria?
Provide a short and direct response. 1.92. In the year 1968, what is the difference between the % of value added in manufacturing of Libya and % of value added in manufacturing of Panama?
Provide a succinct answer. 6.35. In the year 1968, what is the difference between the % of value added in manufacturing in Nigeria and % of value added in manufacturing in Panama?
Offer a terse response. 4.43. In the year 1969, what is the difference between the % of value added in manufacturing of Costa Rica and % of value added in manufacturing of Libya?
Keep it short and to the point. -6.72. In the year 1969, what is the difference between the % of value added in manufacturing in Costa Rica and % of value added in manufacturing in Nigeria?
Offer a very short reply. -1.93. In the year 1969, what is the difference between the % of value added in manufacturing in Costa Rica and % of value added in manufacturing in Panama?
Make the answer very short. 1.02. In the year 1969, what is the difference between the % of value added in manufacturing of Libya and % of value added in manufacturing of Nigeria?
Give a very brief answer. 4.79. In the year 1969, what is the difference between the % of value added in manufacturing of Libya and % of value added in manufacturing of Panama?
Offer a very short reply. 7.74. In the year 1969, what is the difference between the % of value added in manufacturing of Nigeria and % of value added in manufacturing of Panama?
Offer a terse response. 2.95. In the year 1970, what is the difference between the % of value added in manufacturing in Costa Rica and % of value added in manufacturing in Libya?
Your answer should be compact. -5.28. In the year 1970, what is the difference between the % of value added in manufacturing in Costa Rica and % of value added in manufacturing in Nigeria?
Provide a succinct answer. 0.32. In the year 1970, what is the difference between the % of value added in manufacturing in Costa Rica and % of value added in manufacturing in Panama?
Your response must be concise. 1.66. In the year 1970, what is the difference between the % of value added in manufacturing of Libya and % of value added in manufacturing of Nigeria?
Your answer should be very brief. 5.59. In the year 1970, what is the difference between the % of value added in manufacturing of Libya and % of value added in manufacturing of Panama?
Your answer should be very brief. 6.94. In the year 1970, what is the difference between the % of value added in manufacturing in Nigeria and % of value added in manufacturing in Panama?
Ensure brevity in your answer.  1.34. In the year 1971, what is the difference between the % of value added in manufacturing in Costa Rica and % of value added in manufacturing in Libya?
Give a very brief answer. -3.29. In the year 1971, what is the difference between the % of value added in manufacturing of Costa Rica and % of value added in manufacturing of Nigeria?
Your answer should be compact. -1.23. In the year 1971, what is the difference between the % of value added in manufacturing in Costa Rica and % of value added in manufacturing in Panama?
Offer a very short reply. 2.79. In the year 1971, what is the difference between the % of value added in manufacturing of Libya and % of value added in manufacturing of Nigeria?
Offer a terse response. 2.06. In the year 1971, what is the difference between the % of value added in manufacturing of Libya and % of value added in manufacturing of Panama?
Offer a terse response. 6.09. In the year 1971, what is the difference between the % of value added in manufacturing in Nigeria and % of value added in manufacturing in Panama?
Your response must be concise. 4.03. In the year 1972, what is the difference between the % of value added in manufacturing of Costa Rica and % of value added in manufacturing of Libya?
Your answer should be compact. 0.57. In the year 1972, what is the difference between the % of value added in manufacturing in Costa Rica and % of value added in manufacturing in Nigeria?
Your answer should be very brief. -1.21. In the year 1972, what is the difference between the % of value added in manufacturing in Costa Rica and % of value added in manufacturing in Panama?
Give a very brief answer. 2.17. In the year 1972, what is the difference between the % of value added in manufacturing in Libya and % of value added in manufacturing in Nigeria?
Offer a terse response. -1.77. In the year 1972, what is the difference between the % of value added in manufacturing of Libya and % of value added in manufacturing of Panama?
Your answer should be compact. 1.61. In the year 1972, what is the difference between the % of value added in manufacturing in Nigeria and % of value added in manufacturing in Panama?
Your answer should be compact. 3.38. In the year 1973, what is the difference between the % of value added in manufacturing of Costa Rica and % of value added in manufacturing of Libya?
Keep it short and to the point. -4.42. In the year 1973, what is the difference between the % of value added in manufacturing of Costa Rica and % of value added in manufacturing of Nigeria?
Your answer should be very brief. -1.46. In the year 1973, what is the difference between the % of value added in manufacturing in Costa Rica and % of value added in manufacturing in Panama?
Make the answer very short. 2.97. In the year 1973, what is the difference between the % of value added in manufacturing in Libya and % of value added in manufacturing in Nigeria?
Your answer should be compact. 2.96. In the year 1973, what is the difference between the % of value added in manufacturing of Libya and % of value added in manufacturing of Panama?
Make the answer very short. 7.39. In the year 1973, what is the difference between the % of value added in manufacturing in Nigeria and % of value added in manufacturing in Panama?
Your answer should be compact. 4.43. What is the ratio of the % of value added in manufacturing in Costa Rica in 1966 to that in 1967?
Ensure brevity in your answer.  0.93. What is the ratio of the % of value added in manufacturing in Libya in 1966 to that in 1967?
Your answer should be very brief. 1.11. What is the ratio of the % of value added in manufacturing in Nigeria in 1966 to that in 1967?
Provide a short and direct response. 1.63. What is the ratio of the % of value added in manufacturing of Panama in 1966 to that in 1967?
Make the answer very short. 0.92. What is the ratio of the % of value added in manufacturing in Costa Rica in 1966 to that in 1968?
Provide a short and direct response. 0.96. What is the ratio of the % of value added in manufacturing of Libya in 1966 to that in 1968?
Give a very brief answer. 0.99. What is the ratio of the % of value added in manufacturing of Nigeria in 1966 to that in 1968?
Offer a very short reply. 1.51. What is the ratio of the % of value added in manufacturing of Panama in 1966 to that in 1968?
Provide a succinct answer. 0.97. What is the ratio of the % of value added in manufacturing in Costa Rica in 1966 to that in 1969?
Ensure brevity in your answer.  0.96. What is the ratio of the % of value added in manufacturing in Libya in 1966 to that in 1969?
Ensure brevity in your answer.  0.82. What is the ratio of the % of value added in manufacturing of Nigeria in 1966 to that in 1969?
Offer a terse response. 1.62. What is the ratio of the % of value added in manufacturing of Panama in 1966 to that in 1969?
Make the answer very short. 0.81. What is the ratio of the % of value added in manufacturing in Costa Rica in 1966 to that in 1970?
Keep it short and to the point. 0.95. What is the ratio of the % of value added in manufacturing of Libya in 1966 to that in 1970?
Your response must be concise. 0.92. What is the ratio of the % of value added in manufacturing in Nigeria in 1966 to that in 1970?
Your answer should be compact. 2.18. What is the ratio of the % of value added in manufacturing of Panama in 1966 to that in 1970?
Make the answer very short. 0.9. What is the ratio of the % of value added in manufacturing in Costa Rica in 1966 to that in 1971?
Provide a short and direct response. 0.86. What is the ratio of the % of value added in manufacturing in Libya in 1966 to that in 1971?
Your answer should be compact. 1.03. What is the ratio of the % of value added in manufacturing in Nigeria in 1966 to that in 1971?
Your response must be concise. 1.61. What is the ratio of the % of value added in manufacturing in Panama in 1966 to that in 1971?
Your answer should be compact. 0.99. What is the ratio of the % of value added in manufacturing of Costa Rica in 1966 to that in 1972?
Make the answer very short. 0.84. What is the ratio of the % of value added in manufacturing in Libya in 1966 to that in 1972?
Provide a short and direct response. 1.58. What is the ratio of the % of value added in manufacturing in Nigeria in 1966 to that in 1972?
Your response must be concise. 1.57. What is the ratio of the % of value added in manufacturing in Panama in 1966 to that in 1972?
Provide a succinct answer. 0.83. What is the ratio of the % of value added in manufacturing of Costa Rica in 1966 to that in 1973?
Provide a succinct answer. 0.73. What is the ratio of the % of value added in manufacturing of Libya in 1966 to that in 1973?
Give a very brief answer. 0.83. What is the ratio of the % of value added in manufacturing in Nigeria in 1966 to that in 1973?
Offer a very short reply. 1.35. What is the ratio of the % of value added in manufacturing in Panama in 1966 to that in 1973?
Your response must be concise. 0.78. What is the ratio of the % of value added in manufacturing of Costa Rica in 1967 to that in 1968?
Your response must be concise. 1.03. What is the ratio of the % of value added in manufacturing of Libya in 1967 to that in 1968?
Your answer should be compact. 0.9. What is the ratio of the % of value added in manufacturing of Nigeria in 1967 to that in 1968?
Keep it short and to the point. 0.93. What is the ratio of the % of value added in manufacturing of Panama in 1967 to that in 1968?
Keep it short and to the point. 1.06. What is the ratio of the % of value added in manufacturing in Costa Rica in 1967 to that in 1969?
Your answer should be very brief. 1.04. What is the ratio of the % of value added in manufacturing of Libya in 1967 to that in 1969?
Ensure brevity in your answer.  0.74. What is the ratio of the % of value added in manufacturing of Panama in 1967 to that in 1969?
Your response must be concise. 0.88. What is the ratio of the % of value added in manufacturing in Costa Rica in 1967 to that in 1970?
Provide a succinct answer. 1.02. What is the ratio of the % of value added in manufacturing in Libya in 1967 to that in 1970?
Your answer should be very brief. 0.83. What is the ratio of the % of value added in manufacturing of Nigeria in 1967 to that in 1970?
Keep it short and to the point. 1.34. What is the ratio of the % of value added in manufacturing of Panama in 1967 to that in 1970?
Provide a short and direct response. 0.98. What is the ratio of the % of value added in manufacturing in Costa Rica in 1967 to that in 1971?
Your response must be concise. 0.93. What is the ratio of the % of value added in manufacturing in Libya in 1967 to that in 1971?
Give a very brief answer. 0.93. What is the ratio of the % of value added in manufacturing in Nigeria in 1967 to that in 1971?
Ensure brevity in your answer.  0.99. What is the ratio of the % of value added in manufacturing in Panama in 1967 to that in 1971?
Ensure brevity in your answer.  1.08. What is the ratio of the % of value added in manufacturing in Costa Rica in 1967 to that in 1972?
Your answer should be compact. 0.9. What is the ratio of the % of value added in manufacturing of Libya in 1967 to that in 1972?
Keep it short and to the point. 1.43. What is the ratio of the % of value added in manufacturing of Nigeria in 1967 to that in 1972?
Your response must be concise. 0.96. What is the ratio of the % of value added in manufacturing of Panama in 1967 to that in 1972?
Make the answer very short. 0.91. What is the ratio of the % of value added in manufacturing in Costa Rica in 1967 to that in 1973?
Ensure brevity in your answer.  0.78. What is the ratio of the % of value added in manufacturing of Libya in 1967 to that in 1973?
Provide a short and direct response. 0.75. What is the ratio of the % of value added in manufacturing of Nigeria in 1967 to that in 1973?
Your response must be concise. 0.83. What is the ratio of the % of value added in manufacturing in Panama in 1967 to that in 1973?
Make the answer very short. 0.85. What is the ratio of the % of value added in manufacturing of Costa Rica in 1968 to that in 1969?
Your answer should be compact. 1.01. What is the ratio of the % of value added in manufacturing of Libya in 1968 to that in 1969?
Provide a succinct answer. 0.83. What is the ratio of the % of value added in manufacturing of Nigeria in 1968 to that in 1969?
Offer a very short reply. 1.07. What is the ratio of the % of value added in manufacturing in Panama in 1968 to that in 1969?
Offer a terse response. 0.83. What is the ratio of the % of value added in manufacturing of Costa Rica in 1968 to that in 1970?
Make the answer very short. 0.99. What is the ratio of the % of value added in manufacturing in Libya in 1968 to that in 1970?
Keep it short and to the point. 0.92. What is the ratio of the % of value added in manufacturing of Nigeria in 1968 to that in 1970?
Your answer should be very brief. 1.44. What is the ratio of the % of value added in manufacturing in Panama in 1968 to that in 1970?
Provide a succinct answer. 0.93. What is the ratio of the % of value added in manufacturing in Costa Rica in 1968 to that in 1971?
Ensure brevity in your answer.  0.9. What is the ratio of the % of value added in manufacturing of Libya in 1968 to that in 1971?
Give a very brief answer. 1.04. What is the ratio of the % of value added in manufacturing in Nigeria in 1968 to that in 1971?
Keep it short and to the point. 1.06. What is the ratio of the % of value added in manufacturing in Panama in 1968 to that in 1971?
Your response must be concise. 1.03. What is the ratio of the % of value added in manufacturing of Costa Rica in 1968 to that in 1972?
Offer a terse response. 0.87. What is the ratio of the % of value added in manufacturing in Libya in 1968 to that in 1972?
Offer a very short reply. 1.59. What is the ratio of the % of value added in manufacturing in Nigeria in 1968 to that in 1972?
Offer a very short reply. 1.04. What is the ratio of the % of value added in manufacturing in Panama in 1968 to that in 1972?
Offer a very short reply. 0.86. What is the ratio of the % of value added in manufacturing of Costa Rica in 1968 to that in 1973?
Your response must be concise. 0.76. What is the ratio of the % of value added in manufacturing in Libya in 1968 to that in 1973?
Your response must be concise. 0.84. What is the ratio of the % of value added in manufacturing in Nigeria in 1968 to that in 1973?
Give a very brief answer. 0.89. What is the ratio of the % of value added in manufacturing of Panama in 1968 to that in 1973?
Make the answer very short. 0.81. What is the ratio of the % of value added in manufacturing in Costa Rica in 1969 to that in 1970?
Ensure brevity in your answer.  0.99. What is the ratio of the % of value added in manufacturing of Libya in 1969 to that in 1970?
Offer a terse response. 1.12. What is the ratio of the % of value added in manufacturing of Nigeria in 1969 to that in 1970?
Give a very brief answer. 1.35. What is the ratio of the % of value added in manufacturing of Panama in 1969 to that in 1970?
Ensure brevity in your answer.  1.11. What is the ratio of the % of value added in manufacturing of Costa Rica in 1969 to that in 1971?
Keep it short and to the point. 0.9. What is the ratio of the % of value added in manufacturing of Libya in 1969 to that in 1971?
Ensure brevity in your answer.  1.26. What is the ratio of the % of value added in manufacturing in Nigeria in 1969 to that in 1971?
Provide a short and direct response. 0.99. What is the ratio of the % of value added in manufacturing in Panama in 1969 to that in 1971?
Keep it short and to the point. 1.23. What is the ratio of the % of value added in manufacturing of Costa Rica in 1969 to that in 1972?
Your answer should be compact. 0.87. What is the ratio of the % of value added in manufacturing of Libya in 1969 to that in 1972?
Your response must be concise. 1.92. What is the ratio of the % of value added in manufacturing in Nigeria in 1969 to that in 1972?
Your answer should be compact. 0.97. What is the ratio of the % of value added in manufacturing in Panama in 1969 to that in 1972?
Keep it short and to the point. 1.03. What is the ratio of the % of value added in manufacturing in Costa Rica in 1969 to that in 1973?
Ensure brevity in your answer.  0.75. What is the ratio of the % of value added in manufacturing of Libya in 1969 to that in 1973?
Give a very brief answer. 1.02. What is the ratio of the % of value added in manufacturing of Nigeria in 1969 to that in 1973?
Offer a terse response. 0.84. What is the ratio of the % of value added in manufacturing of Panama in 1969 to that in 1973?
Your answer should be very brief. 0.97. What is the ratio of the % of value added in manufacturing of Costa Rica in 1970 to that in 1971?
Give a very brief answer. 0.91. What is the ratio of the % of value added in manufacturing of Libya in 1970 to that in 1971?
Your response must be concise. 1.13. What is the ratio of the % of value added in manufacturing of Nigeria in 1970 to that in 1971?
Give a very brief answer. 0.74. What is the ratio of the % of value added in manufacturing of Panama in 1970 to that in 1971?
Your response must be concise. 1.11. What is the ratio of the % of value added in manufacturing of Costa Rica in 1970 to that in 1972?
Offer a terse response. 0.88. What is the ratio of the % of value added in manufacturing in Libya in 1970 to that in 1972?
Keep it short and to the point. 1.72. What is the ratio of the % of value added in manufacturing in Nigeria in 1970 to that in 1972?
Keep it short and to the point. 0.72. What is the ratio of the % of value added in manufacturing of Panama in 1970 to that in 1972?
Keep it short and to the point. 0.93. What is the ratio of the % of value added in manufacturing in Costa Rica in 1970 to that in 1973?
Keep it short and to the point. 0.76. What is the ratio of the % of value added in manufacturing of Libya in 1970 to that in 1973?
Your answer should be compact. 0.91. What is the ratio of the % of value added in manufacturing in Nigeria in 1970 to that in 1973?
Ensure brevity in your answer.  0.62. What is the ratio of the % of value added in manufacturing in Panama in 1970 to that in 1973?
Ensure brevity in your answer.  0.87. What is the ratio of the % of value added in manufacturing of Costa Rica in 1971 to that in 1972?
Offer a terse response. 0.97. What is the ratio of the % of value added in manufacturing in Libya in 1971 to that in 1972?
Provide a short and direct response. 1.53. What is the ratio of the % of value added in manufacturing in Nigeria in 1971 to that in 1972?
Offer a very short reply. 0.98. What is the ratio of the % of value added in manufacturing in Panama in 1971 to that in 1972?
Offer a terse response. 0.84. What is the ratio of the % of value added in manufacturing in Costa Rica in 1971 to that in 1973?
Your answer should be very brief. 0.84. What is the ratio of the % of value added in manufacturing of Libya in 1971 to that in 1973?
Your answer should be compact. 0.81. What is the ratio of the % of value added in manufacturing in Nigeria in 1971 to that in 1973?
Provide a short and direct response. 0.84. What is the ratio of the % of value added in manufacturing in Panama in 1971 to that in 1973?
Make the answer very short. 0.79. What is the ratio of the % of value added in manufacturing of Costa Rica in 1972 to that in 1973?
Your answer should be compact. 0.87. What is the ratio of the % of value added in manufacturing in Libya in 1972 to that in 1973?
Give a very brief answer. 0.53. What is the ratio of the % of value added in manufacturing in Nigeria in 1972 to that in 1973?
Your answer should be compact. 0.86. What is the ratio of the % of value added in manufacturing of Panama in 1972 to that in 1973?
Offer a very short reply. 0.94. What is the difference between the highest and the second highest % of value added in manufacturing in Costa Rica?
Keep it short and to the point. 1.13. What is the difference between the highest and the second highest % of value added in manufacturing of Libya?
Provide a short and direct response. 0.2. What is the difference between the highest and the second highest % of value added in manufacturing of Nigeria?
Keep it short and to the point. 3.53. What is the difference between the highest and the second highest % of value added in manufacturing in Panama?
Your response must be concise. 0.15. What is the difference between the highest and the lowest % of value added in manufacturing in Costa Rica?
Your response must be concise. 2.33. What is the difference between the highest and the lowest % of value added in manufacturing of Libya?
Keep it short and to the point. 6.31. What is the difference between the highest and the lowest % of value added in manufacturing of Nigeria?
Your answer should be very brief. 7.32. What is the difference between the highest and the lowest % of value added in manufacturing of Panama?
Your answer should be very brief. 1.21. 